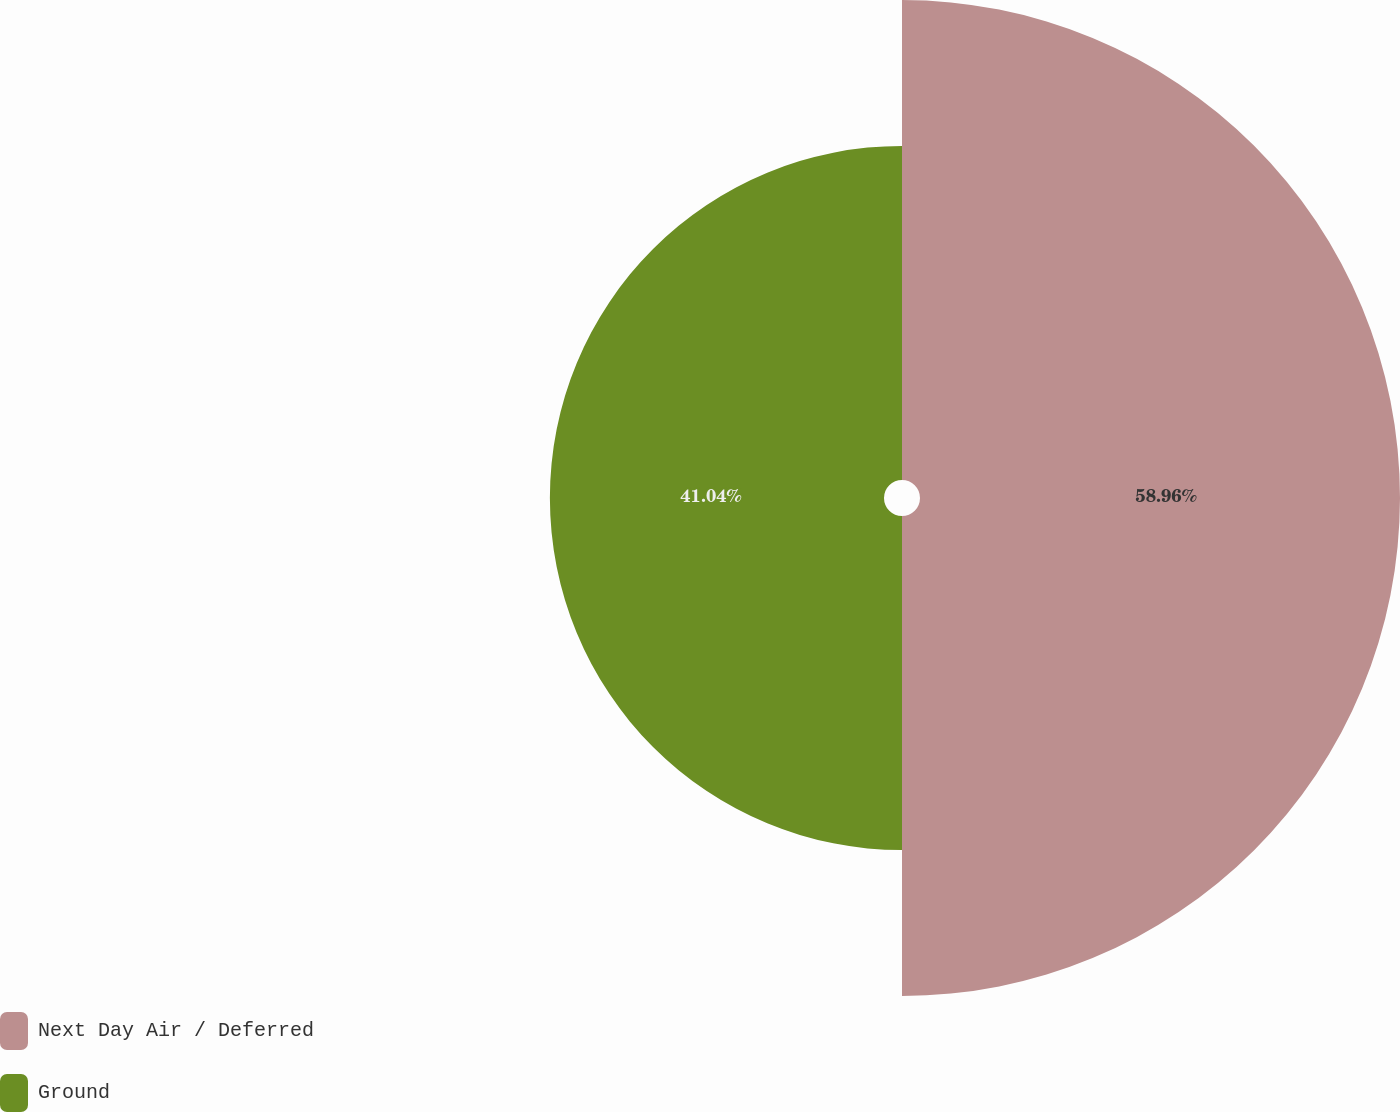<chart> <loc_0><loc_0><loc_500><loc_500><pie_chart><fcel>Next Day Air / Deferred<fcel>Ground<nl><fcel>58.96%<fcel>41.04%<nl></chart> 